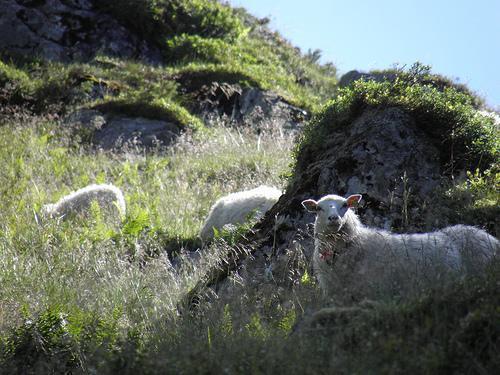How many sheep are there?
Give a very brief answer. 3. How many sheep are looking up?
Give a very brief answer. 1. How many sheep are here?
Give a very brief answer. 3. How many sheep are eating?
Give a very brief answer. 2. 